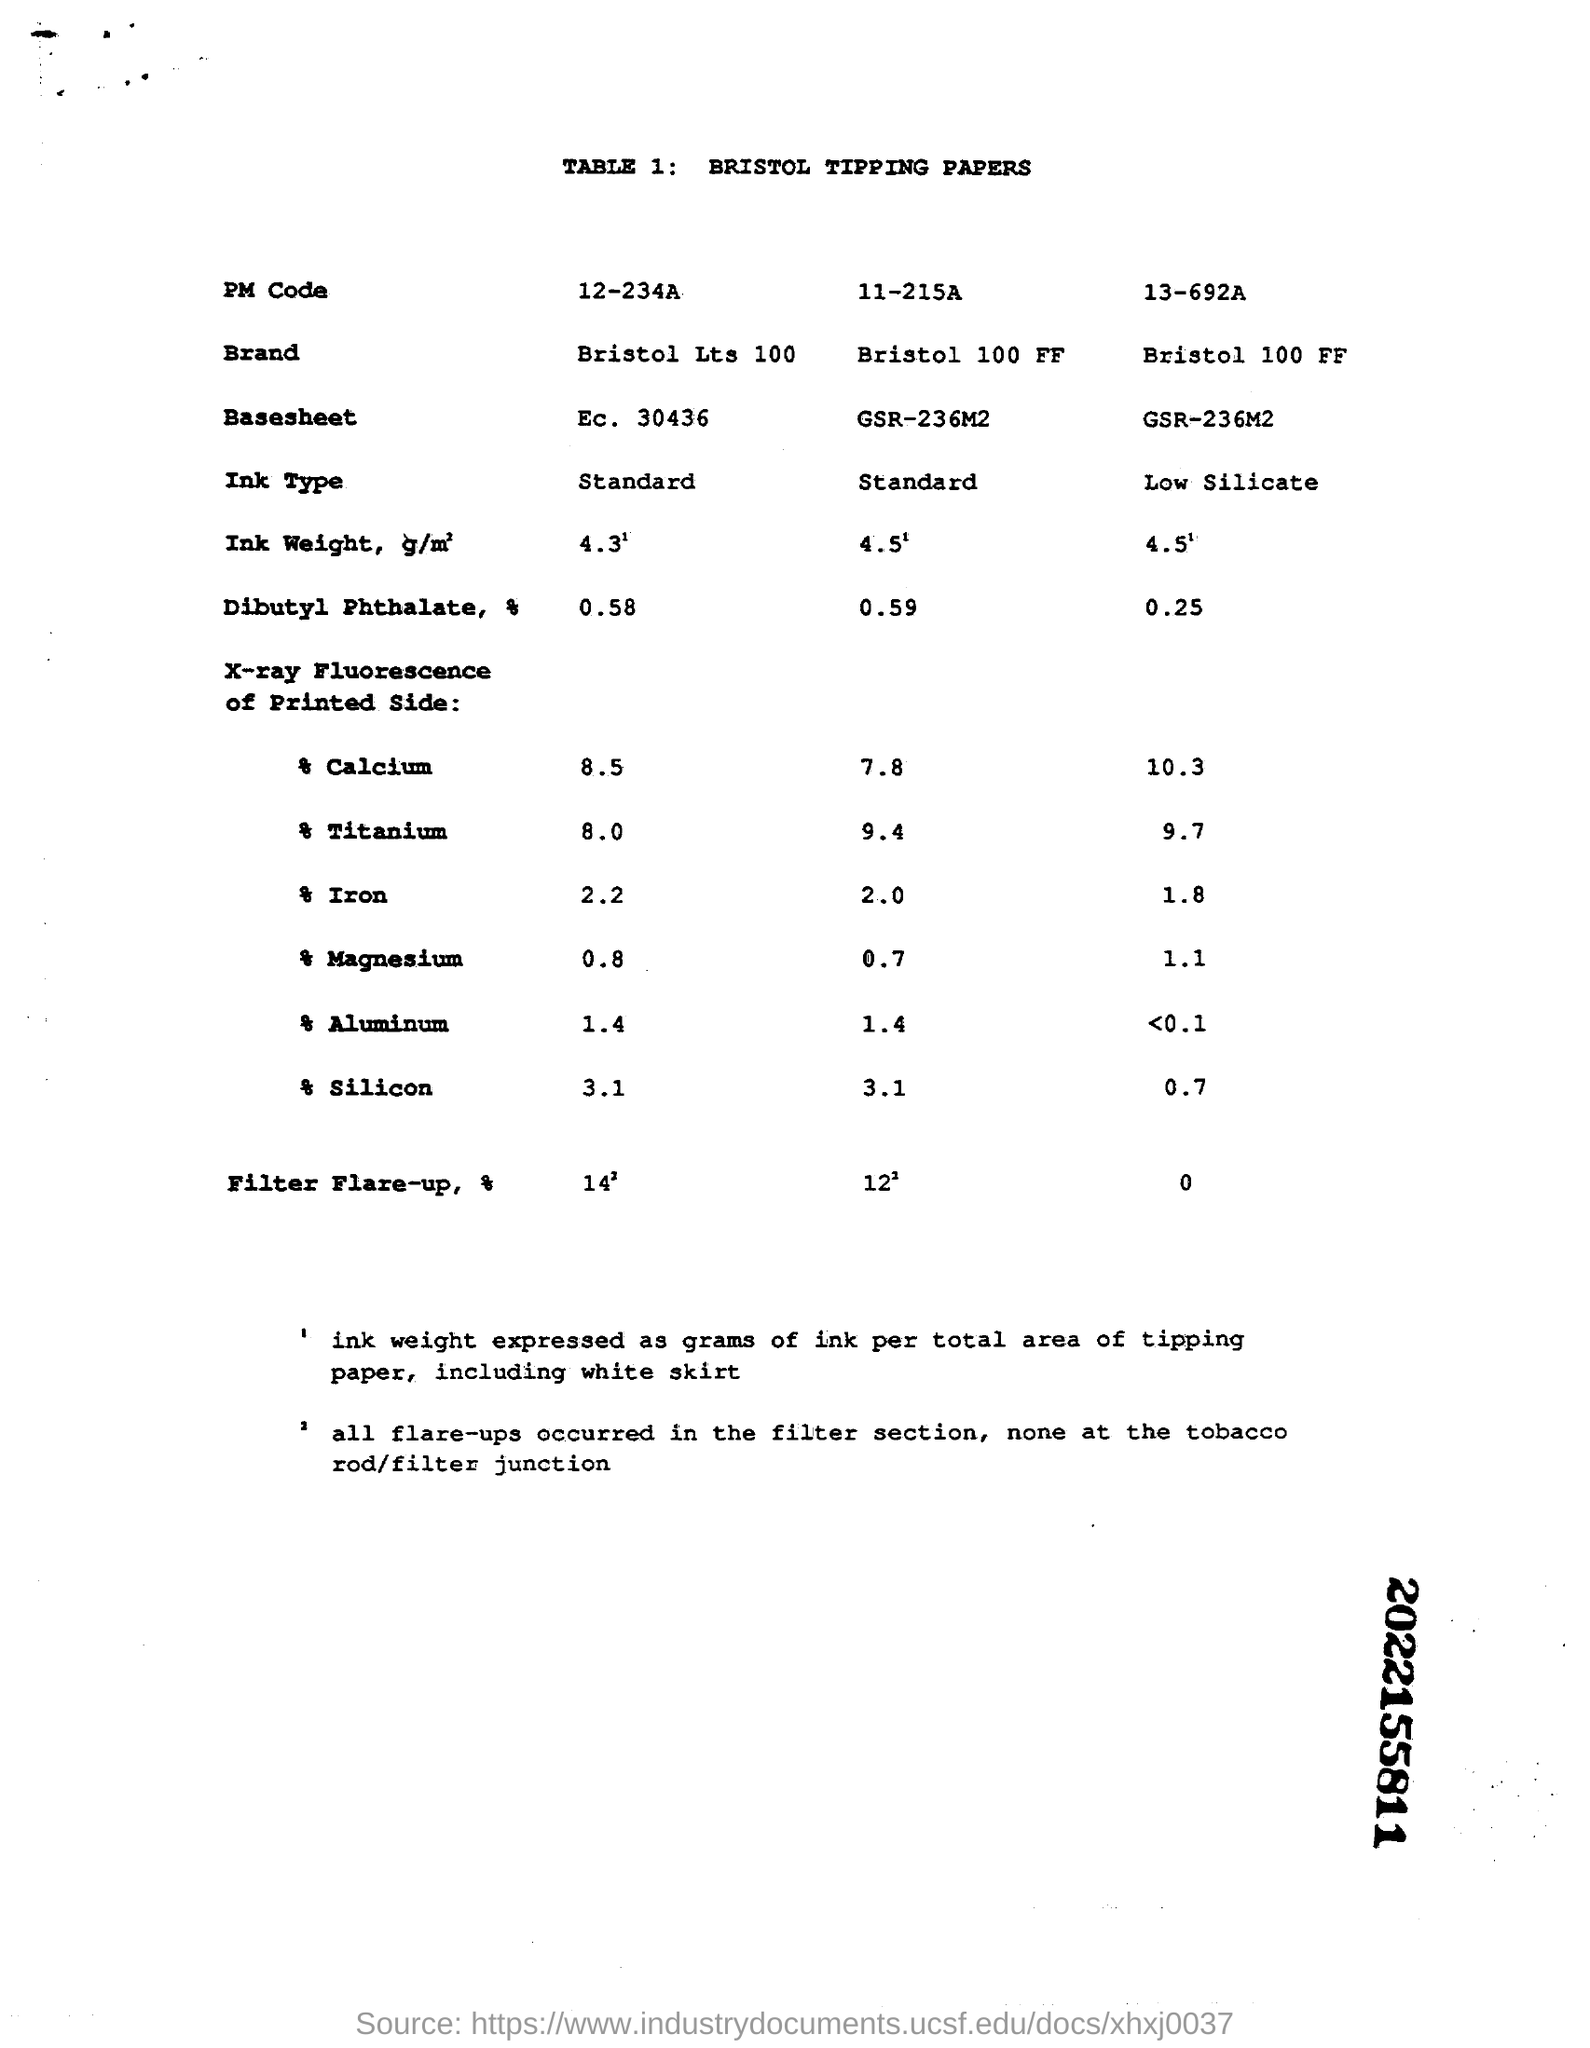What is the title for "TABLE 1"?
Your response must be concise. BRISTOL TIPPING PAPERS. What is the first entity of the "TABLE 1:"?
Offer a terse response. PM Code. What is the "Ink Type" mentioned in the first column of "TABLE 1"?
Provide a succinct answer. Standard. What is the first item entered under "X-ray Flourescence of Printed side:"?
Provide a short and direct response. Calcium. What is the value of "Titanium" entered in the second column  under "X-ray Flourescence of Printed side:"?
Your answer should be very brief. 9.4. What is the "Brand" mentioned in the third column of "TABLE 1"?
Your answer should be very brief. Bristol 100 FF. What is the "PM Code" mentioned in the second column of "TABLE 1"?
Provide a succinct answer. 11-215A. What is the value of "Magnesium" entered in the third column under "X-ray Flourescence of Printed side:"?
Offer a terse response. 1.1. What is the value of "Aluminium" entered in the first column under "X-ray Flourescence of Printed side:"?
Your answer should be compact. 1.4. What is the value of "silicon" entered in the second column under "X-ray Flourescence of Printed side:"?
Provide a short and direct response. 3.1. 